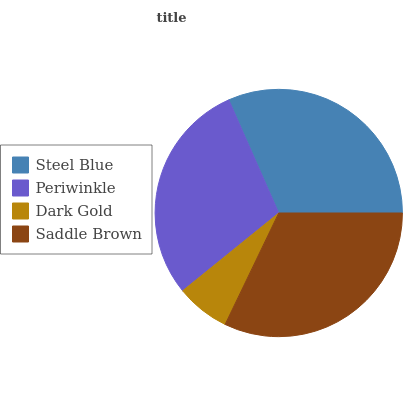Is Dark Gold the minimum?
Answer yes or no. Yes. Is Saddle Brown the maximum?
Answer yes or no. Yes. Is Periwinkle the minimum?
Answer yes or no. No. Is Periwinkle the maximum?
Answer yes or no. No. Is Steel Blue greater than Periwinkle?
Answer yes or no. Yes. Is Periwinkle less than Steel Blue?
Answer yes or no. Yes. Is Periwinkle greater than Steel Blue?
Answer yes or no. No. Is Steel Blue less than Periwinkle?
Answer yes or no. No. Is Steel Blue the high median?
Answer yes or no. Yes. Is Periwinkle the low median?
Answer yes or no. Yes. Is Dark Gold the high median?
Answer yes or no. No. Is Dark Gold the low median?
Answer yes or no. No. 